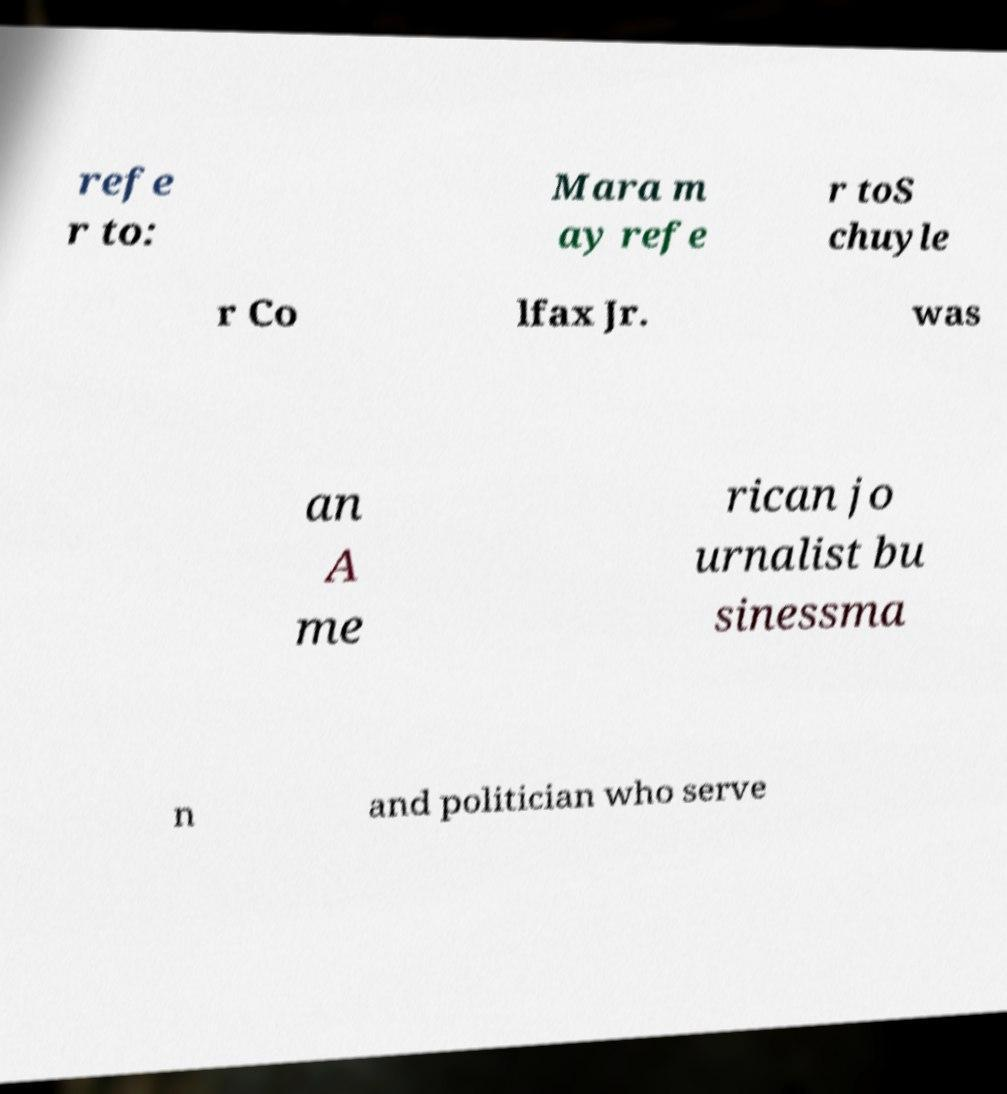Please identify and transcribe the text found in this image. refe r to: Mara m ay refe r toS chuyle r Co lfax Jr. was an A me rican jo urnalist bu sinessma n and politician who serve 